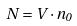<formula> <loc_0><loc_0><loc_500><loc_500>N = V \cdot n _ { 0 }</formula> 